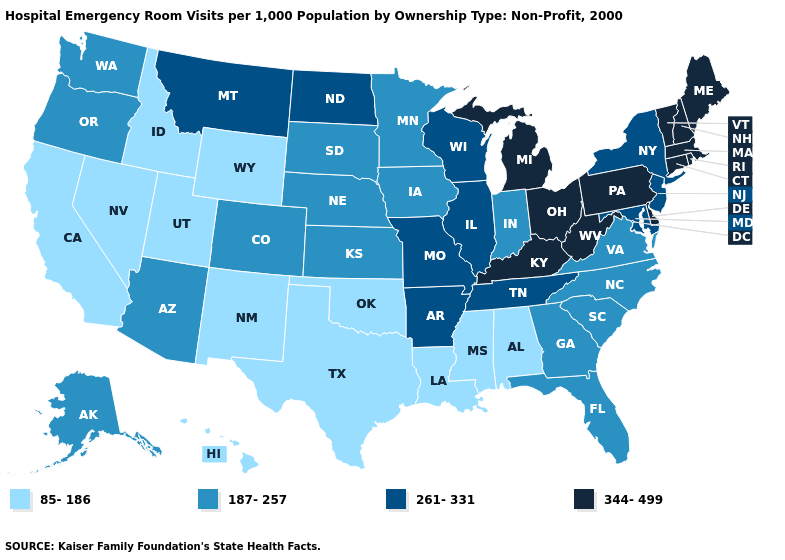Is the legend a continuous bar?
Answer briefly. No. What is the value of Minnesota?
Answer briefly. 187-257. Does Kansas have the lowest value in the USA?
Answer briefly. No. Is the legend a continuous bar?
Write a very short answer. No. Does the first symbol in the legend represent the smallest category?
Be succinct. Yes. Does the first symbol in the legend represent the smallest category?
Concise answer only. Yes. Name the states that have a value in the range 344-499?
Keep it brief. Connecticut, Delaware, Kentucky, Maine, Massachusetts, Michigan, New Hampshire, Ohio, Pennsylvania, Rhode Island, Vermont, West Virginia. What is the value of Connecticut?
Give a very brief answer. 344-499. Does the map have missing data?
Keep it brief. No. Name the states that have a value in the range 187-257?
Be succinct. Alaska, Arizona, Colorado, Florida, Georgia, Indiana, Iowa, Kansas, Minnesota, Nebraska, North Carolina, Oregon, South Carolina, South Dakota, Virginia, Washington. What is the highest value in states that border Massachusetts?
Quick response, please. 344-499. What is the value of Kansas?
Give a very brief answer. 187-257. Does Indiana have the lowest value in the USA?
Concise answer only. No. Name the states that have a value in the range 344-499?
Keep it brief. Connecticut, Delaware, Kentucky, Maine, Massachusetts, Michigan, New Hampshire, Ohio, Pennsylvania, Rhode Island, Vermont, West Virginia. 